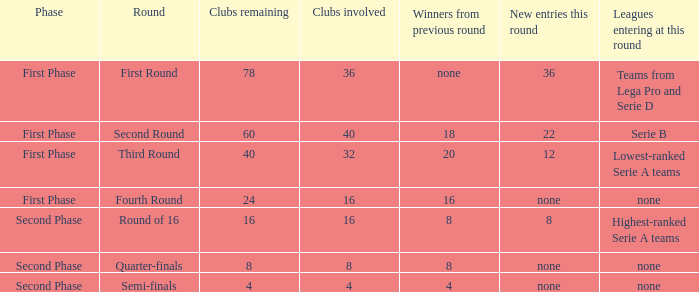Considering the circular label of the third stage, what new inclusions might be encountered during this round? 12.0. 